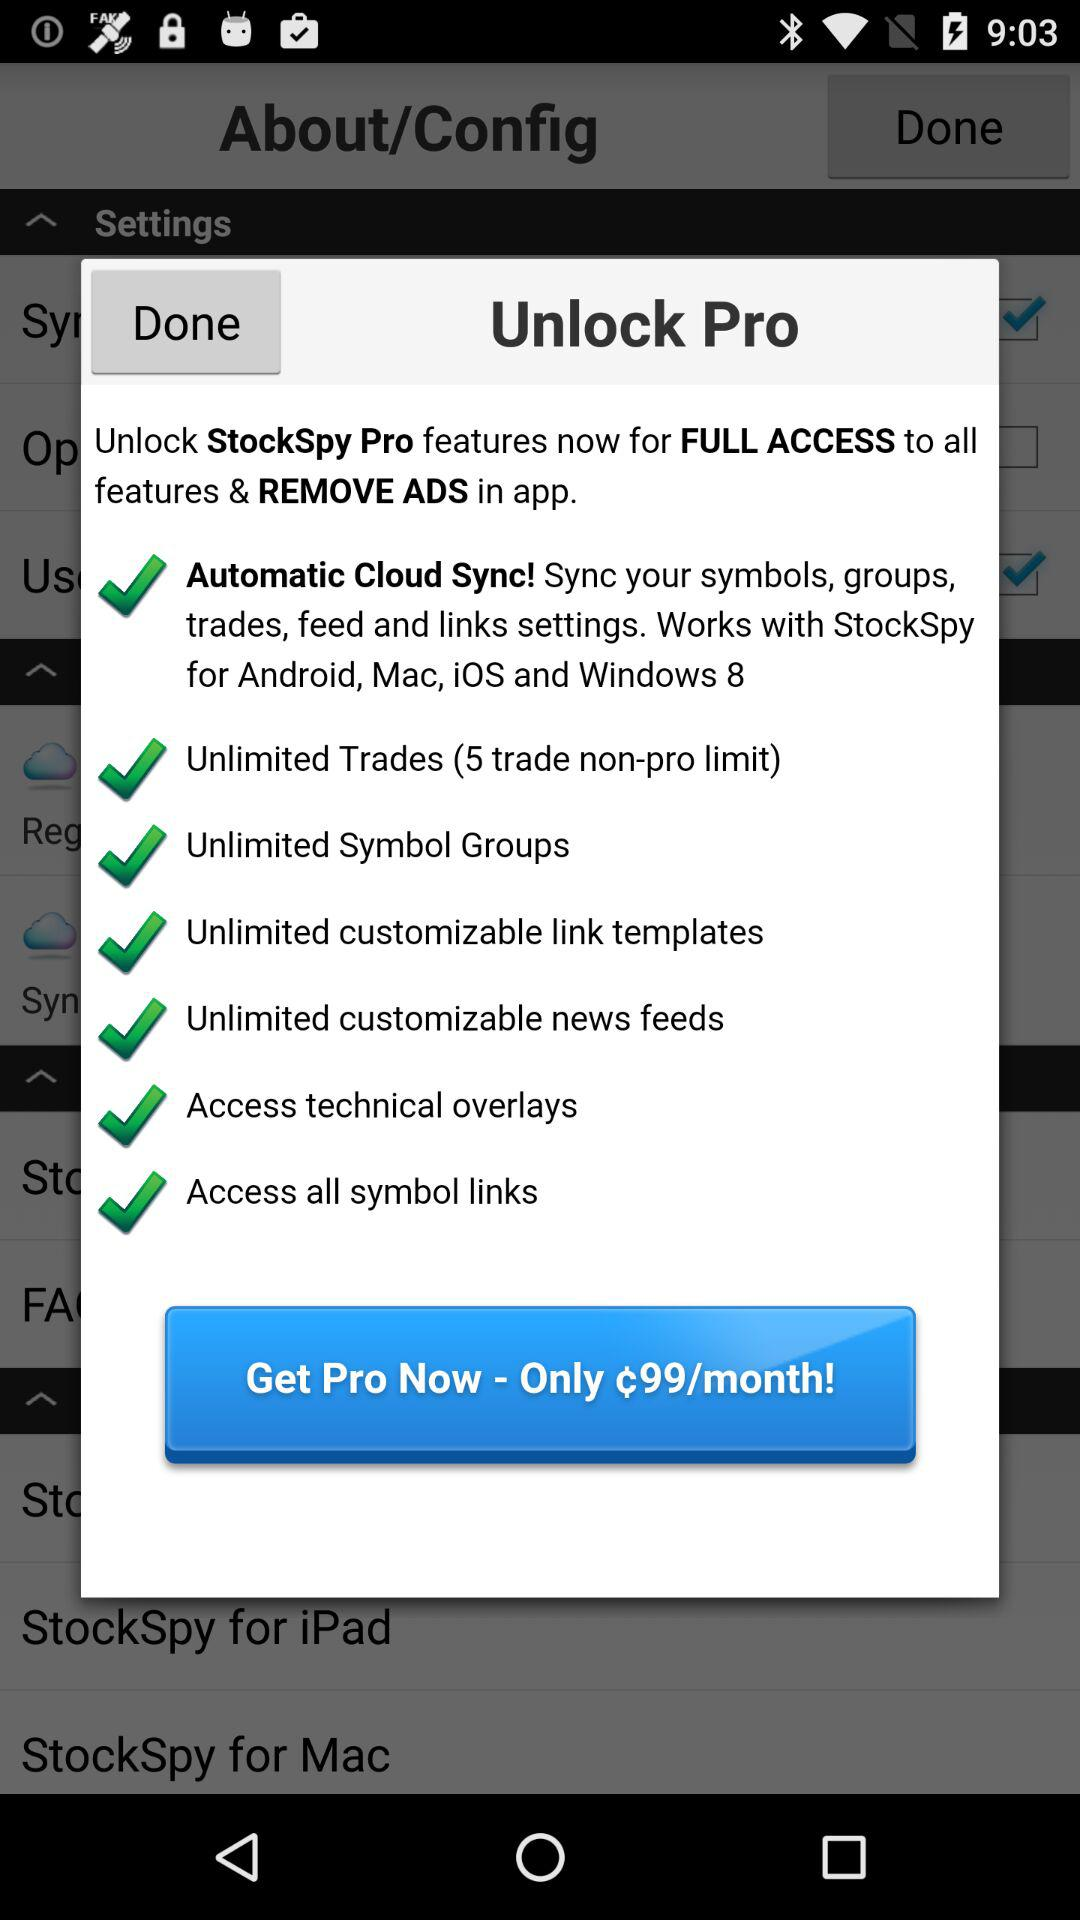How can the user remove ads from the app and have full access to all the features? The user can remove ads from the app and have full access to all the features by unlocking the "StockSpy" pro features. 